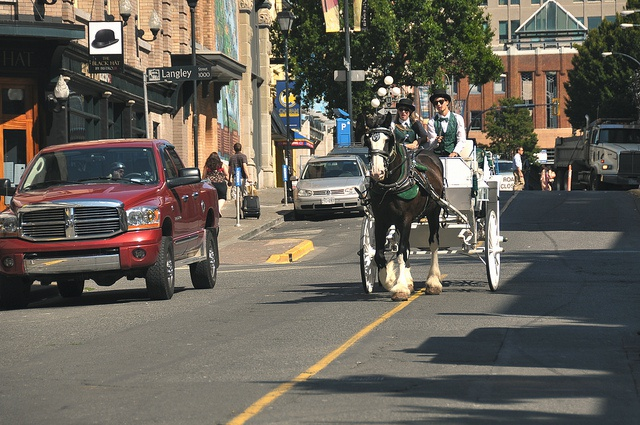Describe the objects in this image and their specific colors. I can see truck in beige, black, gray, maroon, and brown tones, horse in beige, black, gray, and tan tones, truck in beige, black, and gray tones, car in beige, darkgray, black, gray, and ivory tones, and people in beige, black, white, gray, and teal tones in this image. 